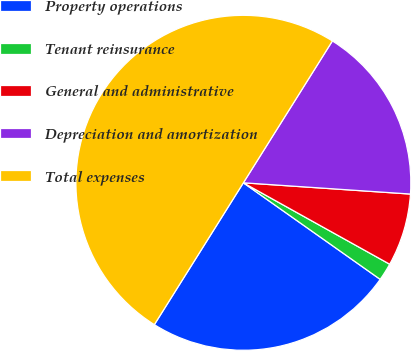Convert chart. <chart><loc_0><loc_0><loc_500><loc_500><pie_chart><fcel>Property operations<fcel>Tenant reinsurance<fcel>General and administrative<fcel>Depreciation and amortization<fcel>Total expenses<nl><fcel>24.14%<fcel>1.7%<fcel>7.01%<fcel>17.15%<fcel>50.0%<nl></chart> 